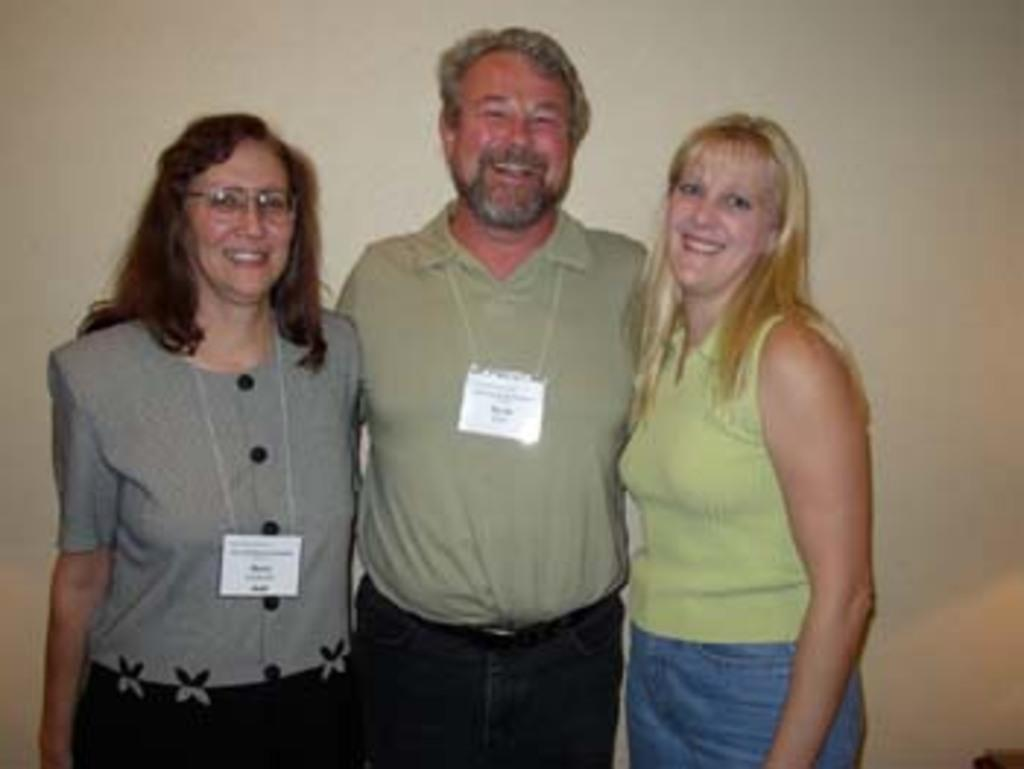How many people are in the image? There are three people in the image. What are the people doing in the image? The three people are standing. What expressions do the people have in the image? The three people are smiling. Are any of the people wearing any identifiable items in the image? Yes, two of the people are wearing ID cards. How many pins are holding the people together in the image? There are no pins present in the image, and the people are not being held together. 